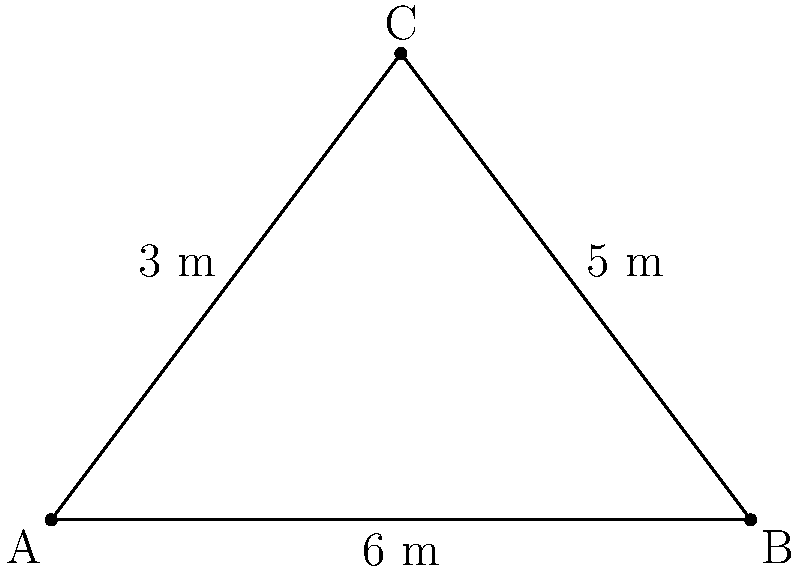On your metal detecting adventure with your grandparent, you discover three buried treasures forming a right-angled triangle. The distance between the first and second treasure is 6 meters, the distance from the second to the third is 5 meters, and the distance from the first to the third is 3 meters. How far apart are the first and second treasures? Let's solve this step-by-step using the Pythagorean theorem:

1. Label the treasures as points A, B, and C, where C is at the right angle.

2. We know:
   - AC = 3 meters
   - BC = 5 meters
   - We need to find AB

3. The Pythagorean theorem states that in a right-angled triangle:
   $a^2 + b^2 = c^2$, where c is the hypotenuse (longest side).

4. In our case:
   $AC^2 + BC^2 = AB^2$

5. Substituting the known values:
   $3^2 + 5^2 = AB^2$

6. Simplify:
   $9 + 25 = AB^2$
   $34 = AB^2$

7. Take the square root of both sides:
   $\sqrt{34} = AB$

8. Simplify:
   $AB = \sqrt{34} \approx 5.83$ meters

Therefore, the distance between the first and second treasures is approximately 5.83 meters.
Answer: $\sqrt{34}$ meters (or approximately 5.83 meters) 